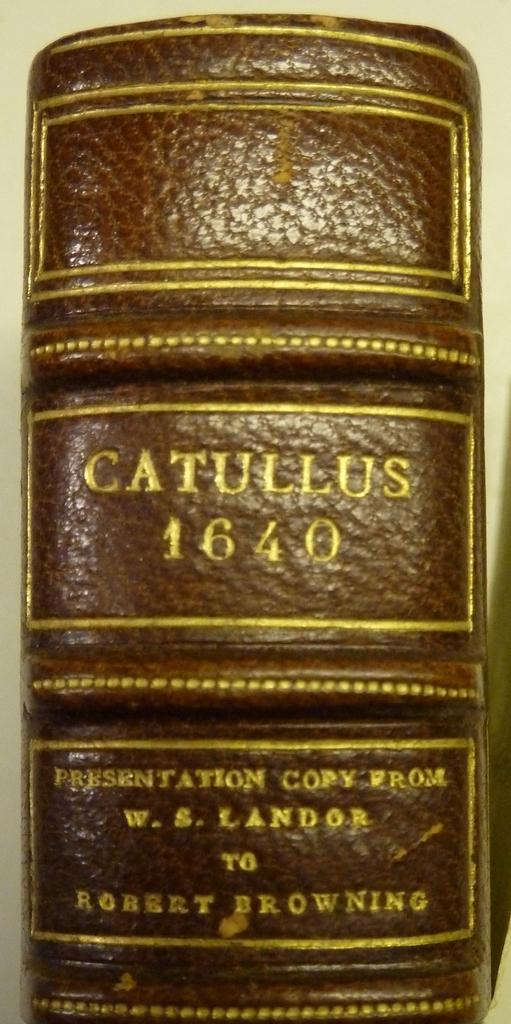<image>
Present a compact description of the photo's key features. A book that has Catullus 1640 written on the spine. 